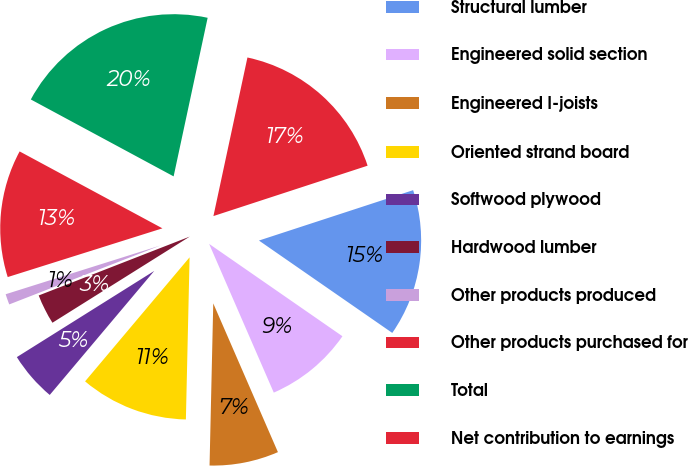Convert chart. <chart><loc_0><loc_0><loc_500><loc_500><pie_chart><fcel>Structural lumber<fcel>Engineered solid section<fcel>Engineered I-joists<fcel>Oriented strand board<fcel>Softwood plywood<fcel>Hardwood lumber<fcel>Other products produced<fcel>Other products purchased for<fcel>Total<fcel>Net contribution to earnings<nl><fcel>14.67%<fcel>8.83%<fcel>6.89%<fcel>10.78%<fcel>4.94%<fcel>3.0%<fcel>1.06%<fcel>12.72%<fcel>20.5%<fcel>16.61%<nl></chart> 